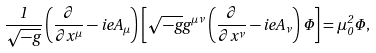Convert formula to latex. <formula><loc_0><loc_0><loc_500><loc_500>\frac { 1 } { \sqrt { - g } } \left ( \frac { \partial } { \partial { x } ^ { \mu } } - i e { A } _ { \mu } \right ) \left [ \sqrt { - g } { g } ^ { \mu \nu } \left ( \frac { \partial } { \partial { x } ^ { \nu } } - i e { A } _ { \nu } \right ) \Phi \right ] = { \mu } _ { 0 } ^ { 2 } \Phi ,</formula> 